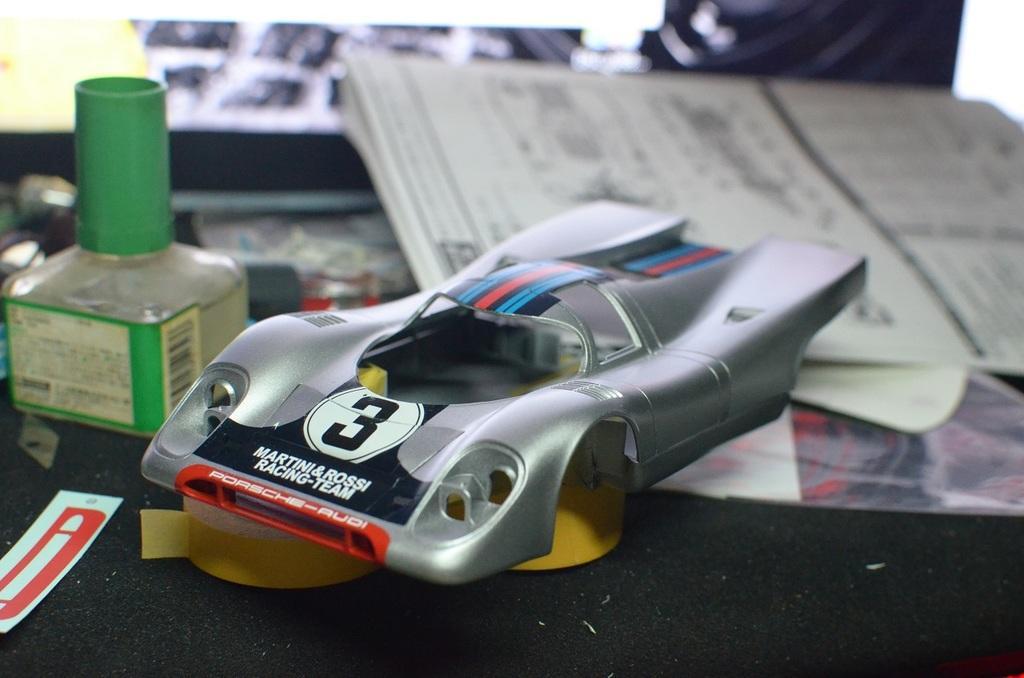Could you give a brief overview of what you see in this image? This image consists of books, papers, toys, plasters. There is some green bottle. 